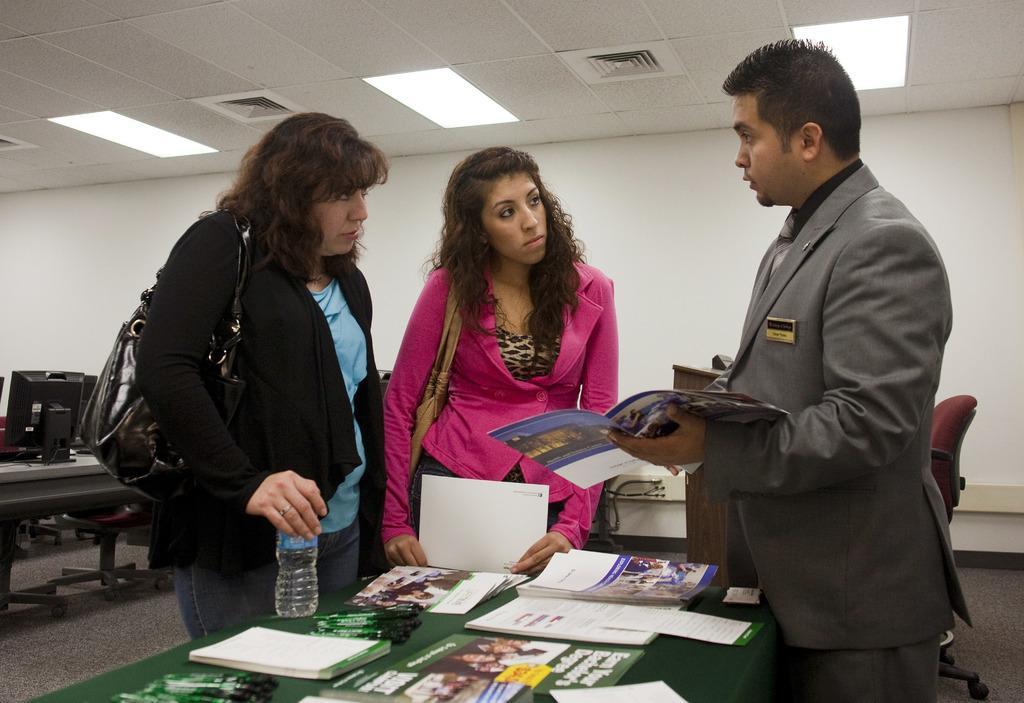How would you summarize this image in a sentence or two? In this image we can see two women and a man are standing and man is holding a book in his hand and two women are holding bottle and a paper in their hands and carrying bags on the shoulder. There are books, posters and objects on a table. In the background there is an object on a podium, chairs on the floor, monitors on the table, wall and lights on the ceiling. 